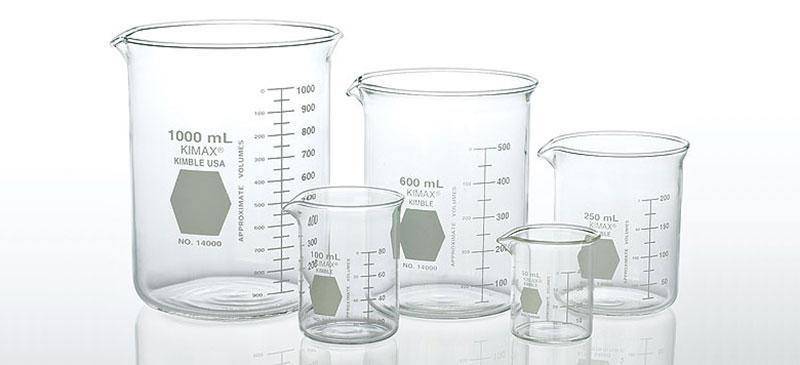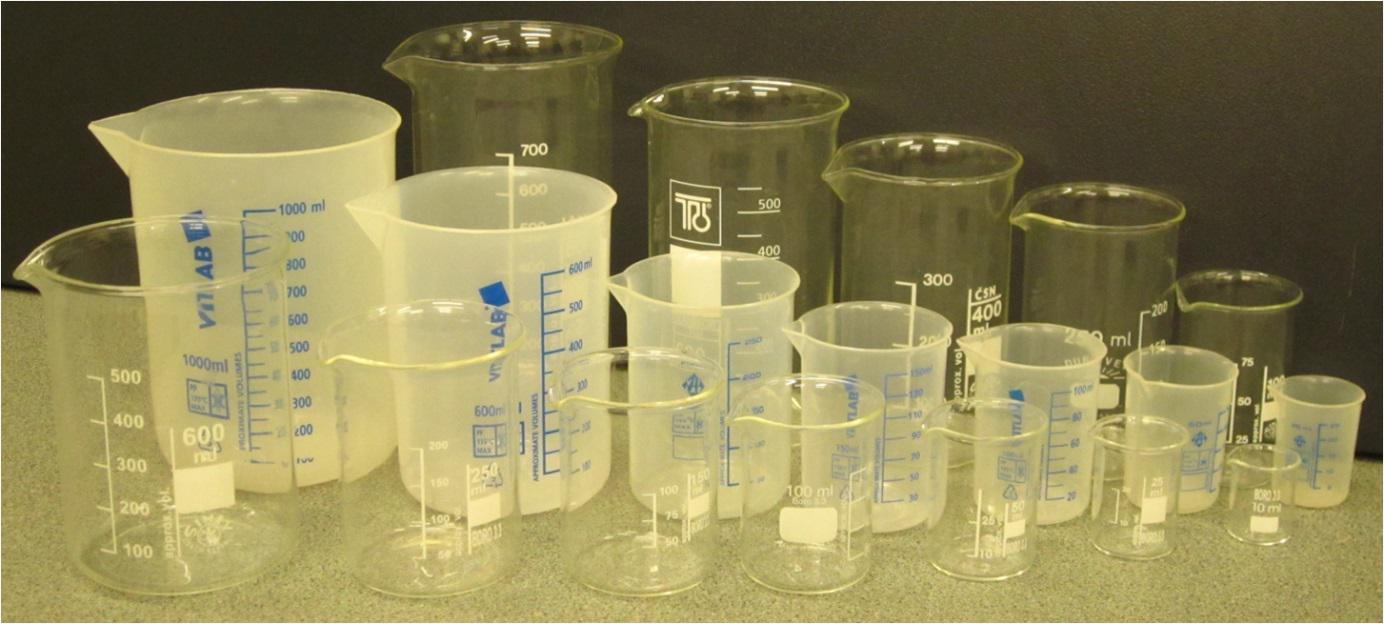The first image is the image on the left, the second image is the image on the right. Analyze the images presented: Is the assertion "There are two beakers with red liquid in them." valid? Answer yes or no. No. The first image is the image on the left, the second image is the image on the right. Analyze the images presented: Is the assertion "There are three beakers on the left, filled with red, blue, and green liquid." valid? Answer yes or no. No. 